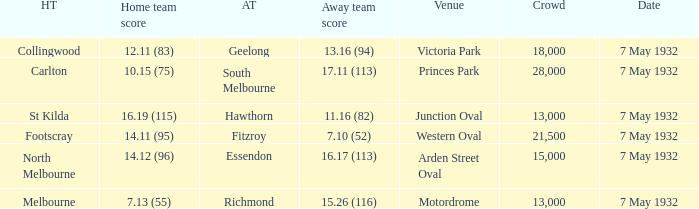Which home team has a Away team of hawthorn? St Kilda. 